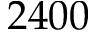<formula> <loc_0><loc_0><loc_500><loc_500>2 4 0 0</formula> 